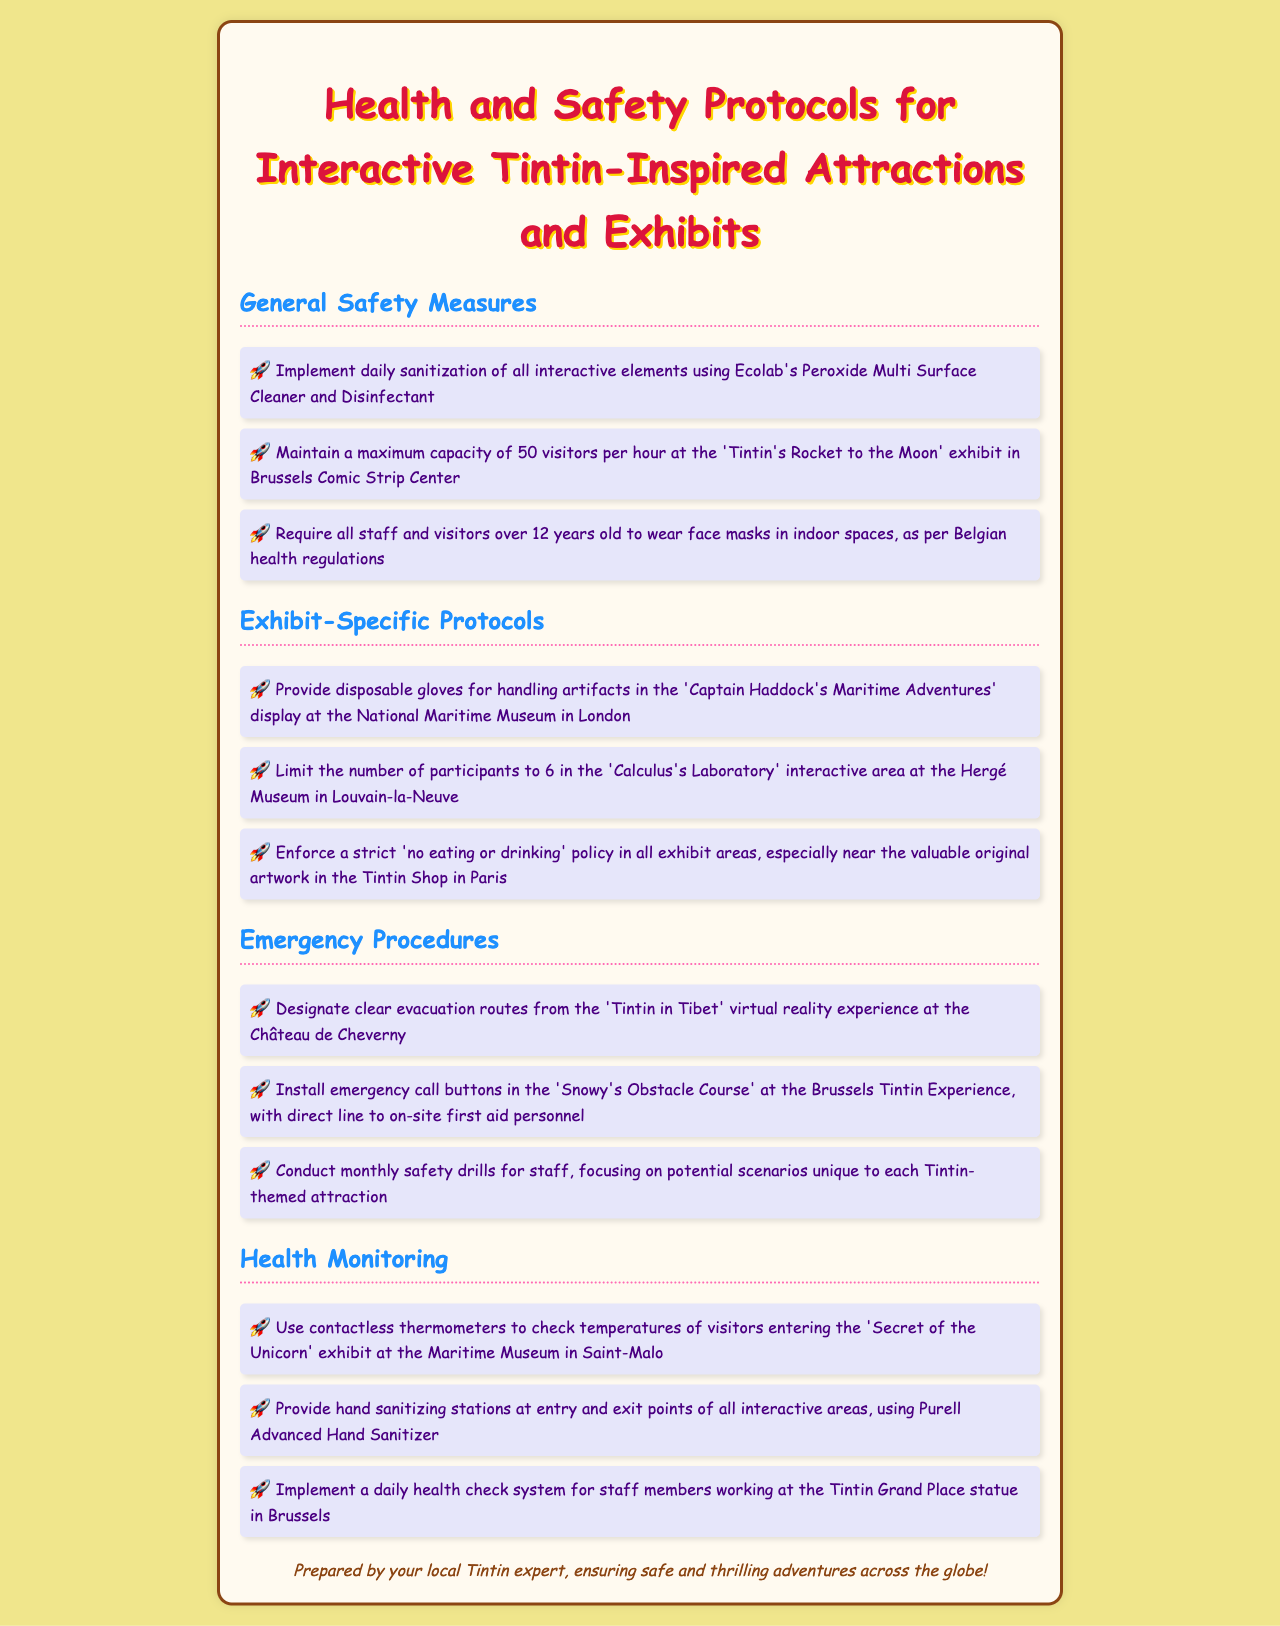what cleaning product is used for sanitization? The document specifies that Ecolab's Peroxide Multi Surface Cleaner and Disinfectant is used for daily sanitization of interactive elements.
Answer: Ecolab's Peroxide Multi Surface Cleaner and Disinfectant what is the maximum visitor capacity for the 'Tintin's Rocket to the Moon' exhibit? The document states that the maximum capacity is 50 visitors per hour.
Answer: 50 visitors per hour how many disposable gloves are provided for the 'Captain Haddock's Maritime Adventures' display? The text mentions that disposable gloves are provided for handling artifacts during the exhibit, but does not specify a number.
Answer: Disposable gloves what is the age requirement for mask-wearing according to Belgian health regulations? The document notes that all staff and visitors over 12 years old are required to wear face masks in indoor spaces.
Answer: 12 years old how many participants are allowed in 'Calculus's Laboratory' interactive area? The document states that the number of participants is limited to 6 in this specific area.
Answer: 6 participants what kind of thermometer is used for health monitoring? The document states that contactless thermometers are used to check temperatures of visitors entering the exhibit.
Answer: Contactless thermometers what health measure is implemented at the Tintin Grand Place statue? The document mentions a daily health check system for staff members working at this location.
Answer: Daily health check system what procedure is in place for emergencies in the 'Snowy's Obstacle Course'? The document details that emergency call buttons are installed with a direct line to on-site first aid personnel.
Answer: Emergency call buttons 